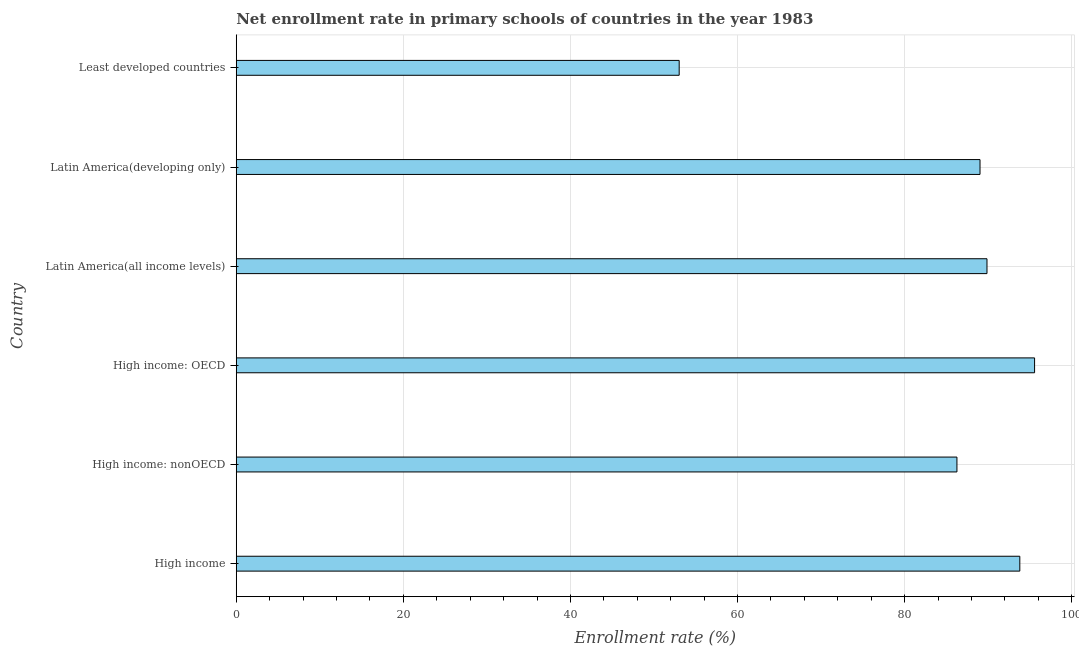Does the graph contain grids?
Your answer should be compact. Yes. What is the title of the graph?
Your answer should be compact. Net enrollment rate in primary schools of countries in the year 1983. What is the label or title of the X-axis?
Offer a terse response. Enrollment rate (%). What is the label or title of the Y-axis?
Offer a very short reply. Country. What is the net enrollment rate in primary schools in High income: OECD?
Provide a short and direct response. 95.55. Across all countries, what is the maximum net enrollment rate in primary schools?
Your answer should be compact. 95.55. Across all countries, what is the minimum net enrollment rate in primary schools?
Your answer should be compact. 53.02. In which country was the net enrollment rate in primary schools maximum?
Your answer should be compact. High income: OECD. In which country was the net enrollment rate in primary schools minimum?
Keep it short and to the point. Least developed countries. What is the sum of the net enrollment rate in primary schools?
Offer a terse response. 507.5. What is the difference between the net enrollment rate in primary schools in High income: nonOECD and Least developed countries?
Provide a succinct answer. 33.24. What is the average net enrollment rate in primary schools per country?
Your answer should be very brief. 84.58. What is the median net enrollment rate in primary schools?
Your answer should be compact. 89.44. What is the ratio of the net enrollment rate in primary schools in High income: OECD to that in High income: nonOECD?
Your answer should be compact. 1.11. What is the difference between the highest and the second highest net enrollment rate in primary schools?
Provide a short and direct response. 1.77. Is the sum of the net enrollment rate in primary schools in High income and Latin America(developing only) greater than the maximum net enrollment rate in primary schools across all countries?
Offer a very short reply. Yes. What is the difference between the highest and the lowest net enrollment rate in primary schools?
Offer a very short reply. 42.54. How many bars are there?
Your response must be concise. 6. How many countries are there in the graph?
Provide a succinct answer. 6. What is the difference between two consecutive major ticks on the X-axis?
Offer a terse response. 20. What is the Enrollment rate (%) in High income?
Your answer should be compact. 93.79. What is the Enrollment rate (%) of High income: nonOECD?
Provide a short and direct response. 86.26. What is the Enrollment rate (%) in High income: OECD?
Offer a terse response. 95.55. What is the Enrollment rate (%) of Latin America(all income levels)?
Provide a short and direct response. 89.86. What is the Enrollment rate (%) in Latin America(developing only)?
Provide a succinct answer. 89.02. What is the Enrollment rate (%) in Least developed countries?
Provide a succinct answer. 53.02. What is the difference between the Enrollment rate (%) in High income and High income: nonOECD?
Your answer should be very brief. 7.53. What is the difference between the Enrollment rate (%) in High income and High income: OECD?
Your answer should be compact. -1.77. What is the difference between the Enrollment rate (%) in High income and Latin America(all income levels)?
Keep it short and to the point. 3.93. What is the difference between the Enrollment rate (%) in High income and Latin America(developing only)?
Make the answer very short. 4.76. What is the difference between the Enrollment rate (%) in High income and Least developed countries?
Your answer should be compact. 40.77. What is the difference between the Enrollment rate (%) in High income: nonOECD and High income: OECD?
Offer a very short reply. -9.29. What is the difference between the Enrollment rate (%) in High income: nonOECD and Latin America(all income levels)?
Your answer should be very brief. -3.6. What is the difference between the Enrollment rate (%) in High income: nonOECD and Latin America(developing only)?
Provide a succinct answer. -2.76. What is the difference between the Enrollment rate (%) in High income: nonOECD and Least developed countries?
Keep it short and to the point. 33.24. What is the difference between the Enrollment rate (%) in High income: OECD and Latin America(all income levels)?
Provide a short and direct response. 5.7. What is the difference between the Enrollment rate (%) in High income: OECD and Latin America(developing only)?
Provide a succinct answer. 6.53. What is the difference between the Enrollment rate (%) in High income: OECD and Least developed countries?
Keep it short and to the point. 42.54. What is the difference between the Enrollment rate (%) in Latin America(all income levels) and Latin America(developing only)?
Offer a terse response. 0.83. What is the difference between the Enrollment rate (%) in Latin America(all income levels) and Least developed countries?
Provide a short and direct response. 36.84. What is the difference between the Enrollment rate (%) in Latin America(developing only) and Least developed countries?
Provide a succinct answer. 36.01. What is the ratio of the Enrollment rate (%) in High income to that in High income: nonOECD?
Offer a terse response. 1.09. What is the ratio of the Enrollment rate (%) in High income to that in High income: OECD?
Make the answer very short. 0.98. What is the ratio of the Enrollment rate (%) in High income to that in Latin America(all income levels)?
Offer a terse response. 1.04. What is the ratio of the Enrollment rate (%) in High income to that in Latin America(developing only)?
Ensure brevity in your answer.  1.05. What is the ratio of the Enrollment rate (%) in High income to that in Least developed countries?
Provide a short and direct response. 1.77. What is the ratio of the Enrollment rate (%) in High income: nonOECD to that in High income: OECD?
Provide a short and direct response. 0.9. What is the ratio of the Enrollment rate (%) in High income: nonOECD to that in Latin America(all income levels)?
Your response must be concise. 0.96. What is the ratio of the Enrollment rate (%) in High income: nonOECD to that in Latin America(developing only)?
Offer a terse response. 0.97. What is the ratio of the Enrollment rate (%) in High income: nonOECD to that in Least developed countries?
Ensure brevity in your answer.  1.63. What is the ratio of the Enrollment rate (%) in High income: OECD to that in Latin America(all income levels)?
Keep it short and to the point. 1.06. What is the ratio of the Enrollment rate (%) in High income: OECD to that in Latin America(developing only)?
Your response must be concise. 1.07. What is the ratio of the Enrollment rate (%) in High income: OECD to that in Least developed countries?
Make the answer very short. 1.8. What is the ratio of the Enrollment rate (%) in Latin America(all income levels) to that in Least developed countries?
Offer a very short reply. 1.7. What is the ratio of the Enrollment rate (%) in Latin America(developing only) to that in Least developed countries?
Your answer should be very brief. 1.68. 